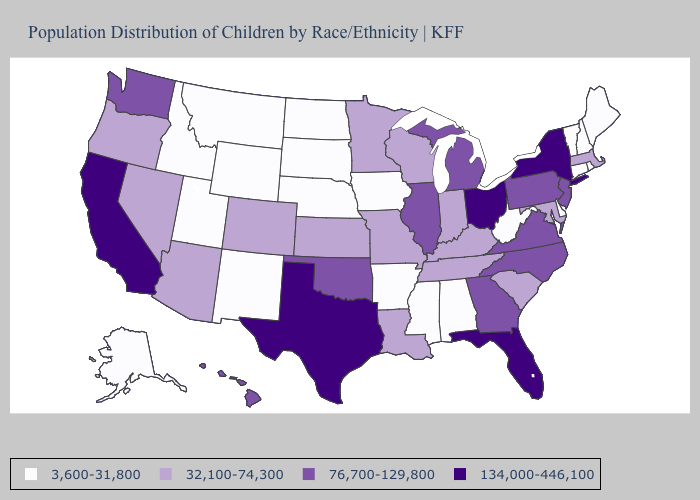What is the highest value in the USA?
Write a very short answer. 134,000-446,100. Which states have the lowest value in the Northeast?
Keep it brief. Connecticut, Maine, New Hampshire, Rhode Island, Vermont. Does Florida have the highest value in the USA?
Keep it brief. Yes. What is the lowest value in the USA?
Be succinct. 3,600-31,800. Name the states that have a value in the range 76,700-129,800?
Keep it brief. Georgia, Hawaii, Illinois, Michigan, New Jersey, North Carolina, Oklahoma, Pennsylvania, Virginia, Washington. Among the states that border Mississippi , which have the lowest value?
Keep it brief. Alabama, Arkansas. Does Oklahoma have a lower value than Colorado?
Concise answer only. No. Does the first symbol in the legend represent the smallest category?
Write a very short answer. Yes. What is the value of Nebraska?
Be succinct. 3,600-31,800. What is the value of North Carolina?
Write a very short answer. 76,700-129,800. Which states hav the highest value in the West?
Be succinct. California. Is the legend a continuous bar?
Short answer required. No. Which states have the highest value in the USA?
Short answer required. California, Florida, New York, Ohio, Texas. Does Michigan have a higher value than Louisiana?
Give a very brief answer. Yes. What is the value of West Virginia?
Write a very short answer. 3,600-31,800. 